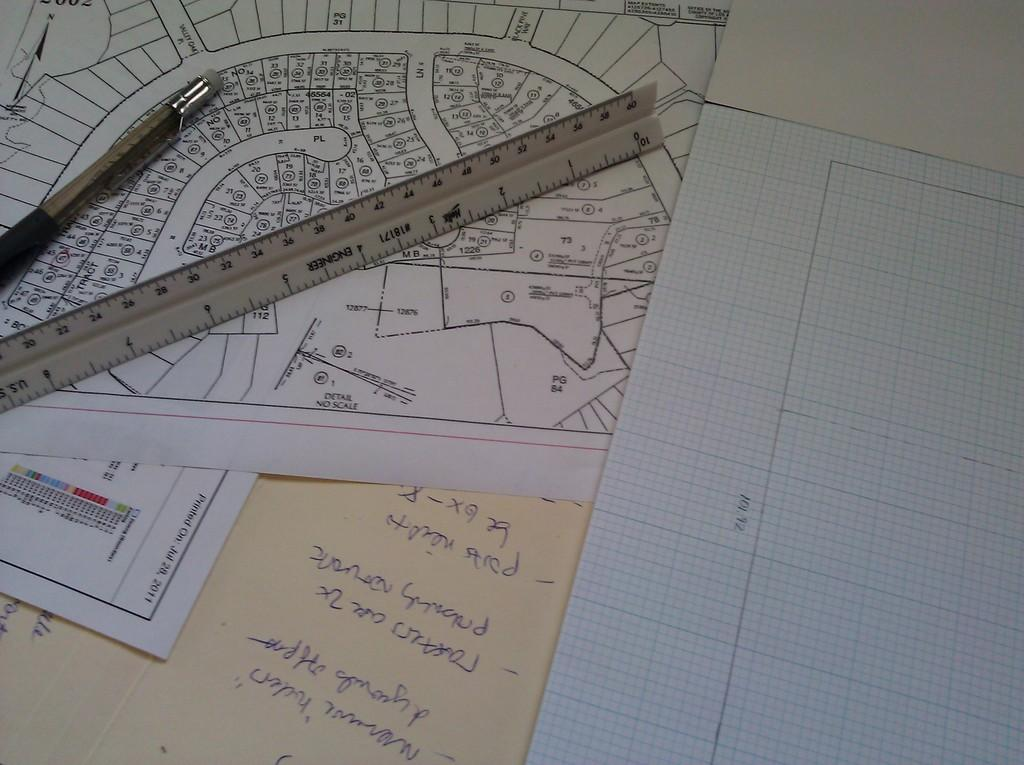<image>
Describe the image concisely. Scattered papers on a desk reveal the date of July 28, 2011 on one of them. 